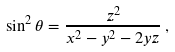Convert formula to latex. <formula><loc_0><loc_0><loc_500><loc_500>\sin ^ { 2 } \theta = \frac { z ^ { 2 } } { x ^ { 2 } - y ^ { 2 } - 2 y z } \, ,</formula> 